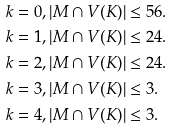Convert formula to latex. <formula><loc_0><loc_0><loc_500><loc_500>& k = 0 , | M \cap V ( K ) | \leq 5 6 . \\ & k = 1 , | M \cap V ( K ) | \leq 2 4 . \\ & k = 2 , | M \cap V ( K ) | \leq 2 4 . \\ & k = 3 , | M \cap V ( K ) | \leq 3 . \\ & k = 4 , | M \cap V ( K ) | \leq 3 . \\</formula> 